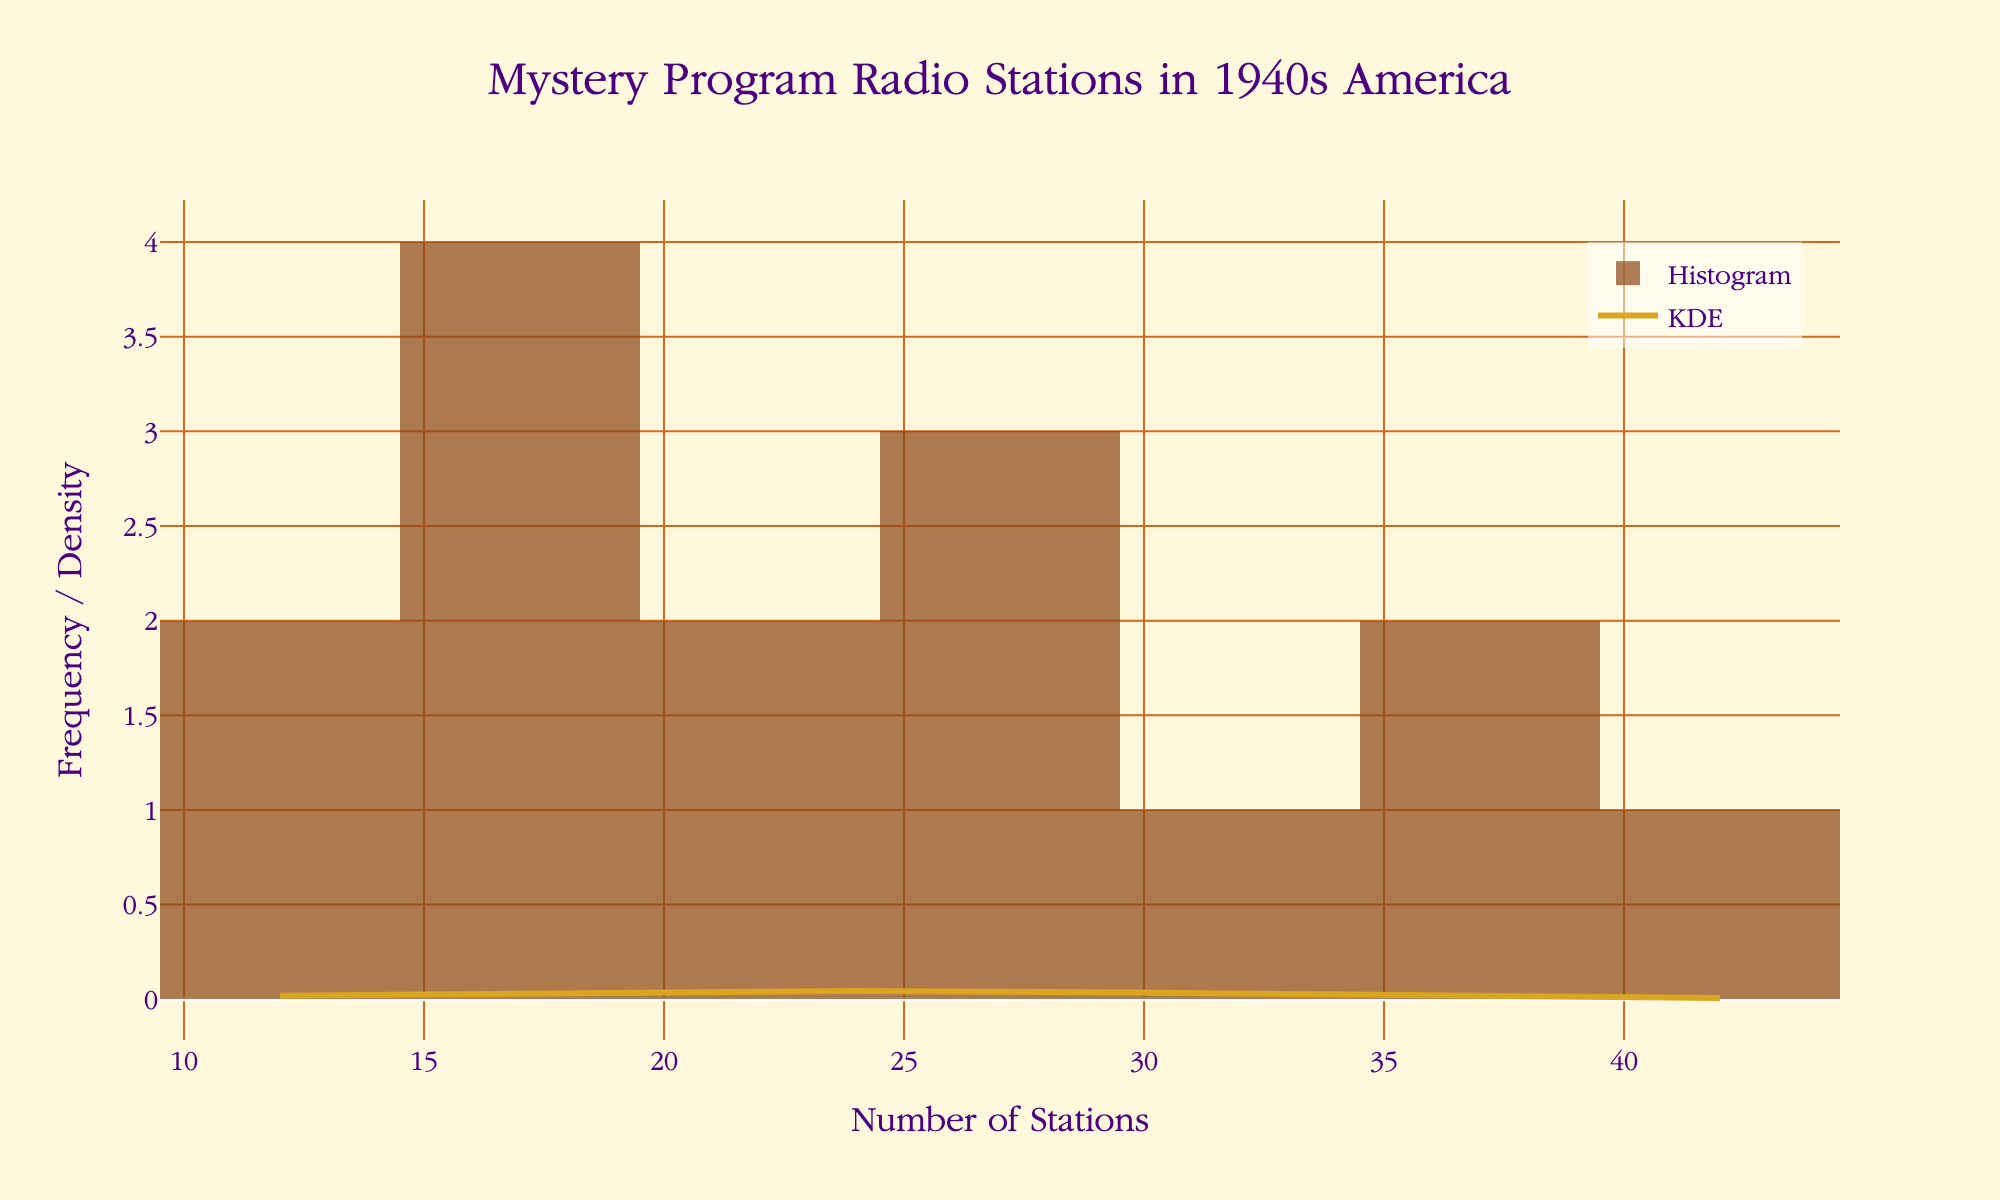What is the title of the figure? The title is located at the top center of the plot and is the most prominent text element.
Answer: Mystery Program Radio Stations in 1940s America What color is used for the histogram bars? The color of the histogram bars is consistent throughout, making it easy to identify.
Answer: Brown How many bins are used in the histogram? You can count the number of bar groups in the histogram to determine the number of bins.
Answer: 10 What is the x-axis labeled as? The x-axis label is positioned below the x-axis line, clearly indicating what the axis represents.
Answer: Number of Stations What is the y-axis labeled as? The y-axis label is positioned along the y-axis line, clearly indicating what the axis represents.
Answer: Frequency / Density How many regions have more than 30 radio stations? Identify the bars in the histogram that extend beyond the x-axis mark of 30 and count them.
Answer: 4 Which region has the fewest number of radio stations? From the data used to generate the plot, identify the region with the lowest count.
Answer: Rocky Mountain What is the average number of radio stations across the regions? Add all the numbers of stations together and divide by the number of regions to get the average. \( \frac{42+38+35+29+18+31+27+22+15+20+12+14+25+16+19}{15} \approx 25 \)
Answer: 25 Is the KDE curve symmetric around the mean number of radio stations? Observe the KDE curve to see if both sides around the mean value (approximately at 25) are mirror images of each other.
Answer: Yes Which regions have fewer than 20 radio stations? Using the provided data, list the regions with values less than 20.
Answer: New England, Pacific Northwest, California, Rocky Mountain, Great Plains, Appalachia, Gulf Coast 